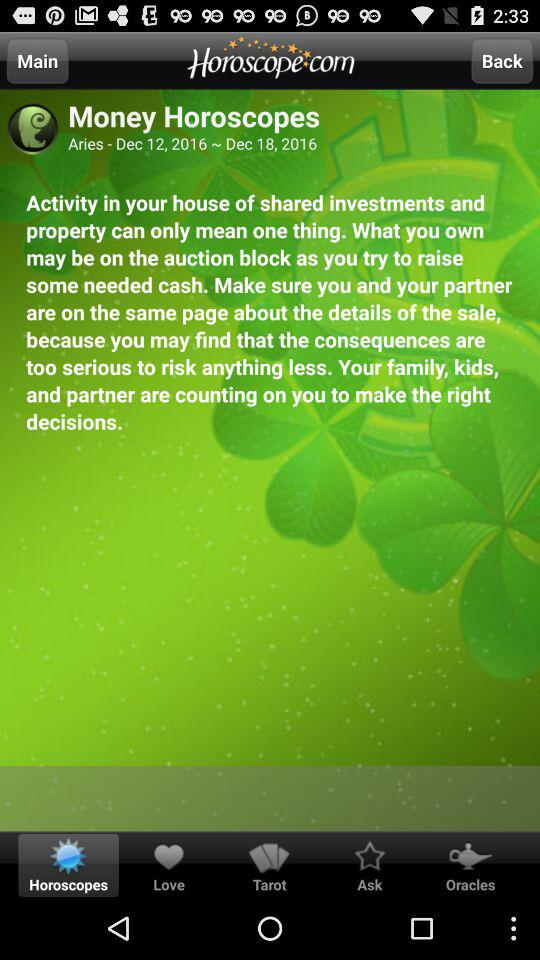What is the date range for the horoscope? The date range for the horoscope is from December 12, 2016 to December 18, 2016. 